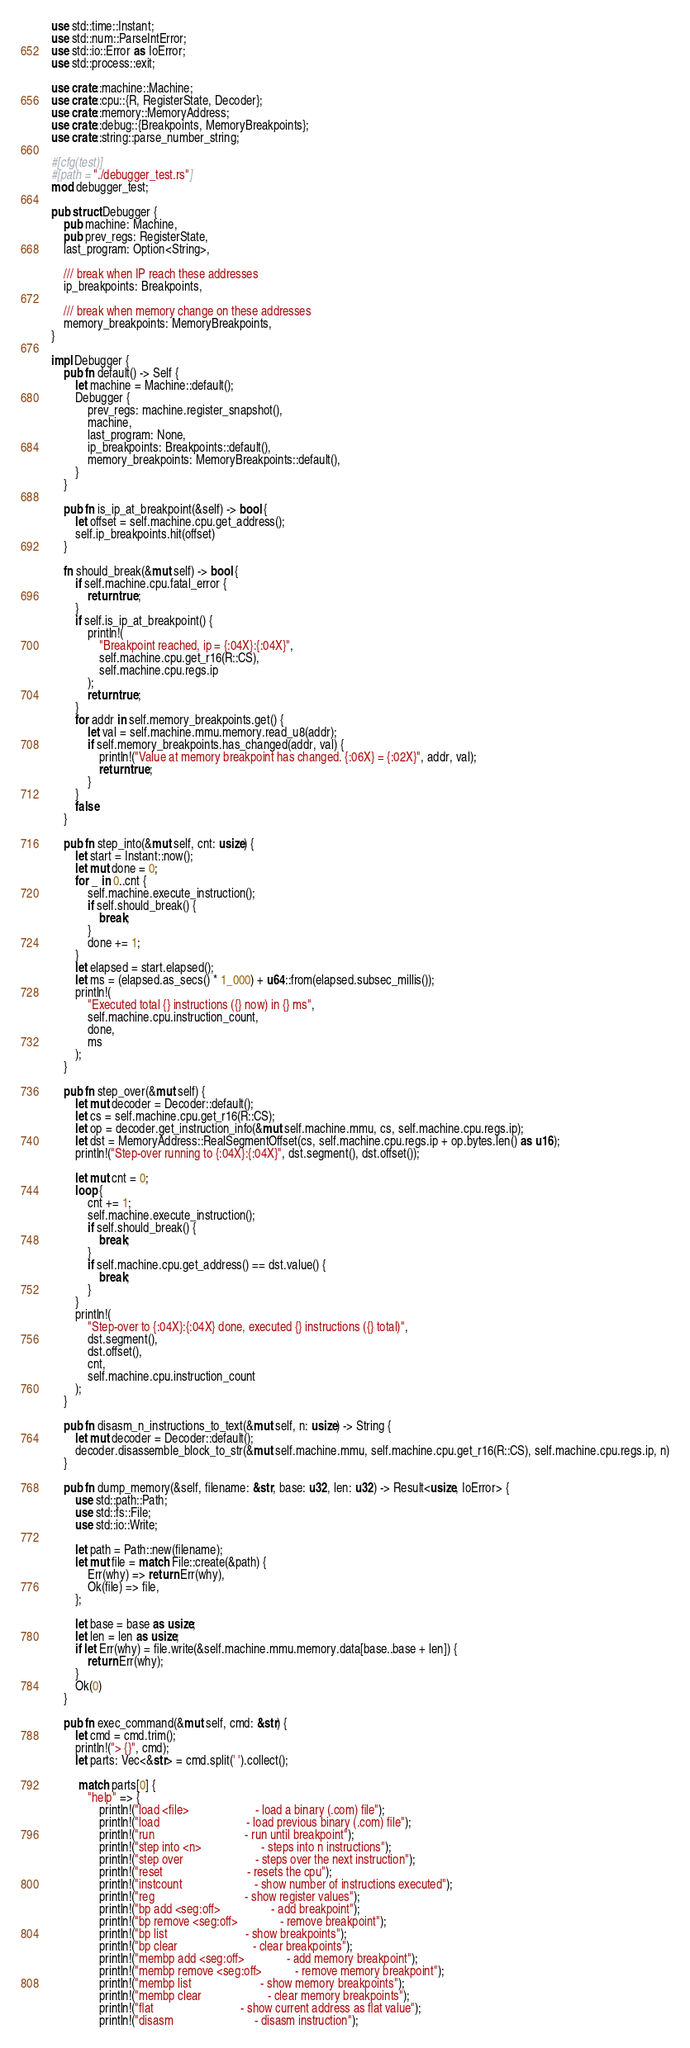Convert code to text. <code><loc_0><loc_0><loc_500><loc_500><_Rust_>use std::time::Instant;
use std::num::ParseIntError;
use std::io::Error as IoError;
use std::process::exit;

use crate::machine::Machine;
use crate::cpu::{R, RegisterState, Decoder};
use crate::memory::MemoryAddress;
use crate::debug::{Breakpoints, MemoryBreakpoints};
use crate::string::parse_number_string;

#[cfg(test)]
#[path = "./debugger_test.rs"]
mod debugger_test;

pub struct Debugger {
    pub machine: Machine,
    pub prev_regs: RegisterState,
    last_program: Option<String>,

    /// break when IP reach these addresses
    ip_breakpoints: Breakpoints,

    /// break when memory change on these addresses
    memory_breakpoints: MemoryBreakpoints,
}

impl Debugger {
    pub fn default() -> Self {
        let machine = Machine::default();
        Debugger {
            prev_regs: machine.register_snapshot(),
            machine,
            last_program: None,
            ip_breakpoints: Breakpoints::default(),
            memory_breakpoints: MemoryBreakpoints::default(),
        }
    }

    pub fn is_ip_at_breakpoint(&self) -> bool {
        let offset = self.machine.cpu.get_address();
        self.ip_breakpoints.hit(offset)
    }

    fn should_break(&mut self) -> bool {
        if self.machine.cpu.fatal_error {
            return true;
        }
        if self.is_ip_at_breakpoint() {
            println!(
                "Breakpoint reached, ip = {:04X}:{:04X}",
                self.machine.cpu.get_r16(R::CS),
                self.machine.cpu.regs.ip
            );
            return true;
        }
        for addr in self.memory_breakpoints.get() {
            let val = self.machine.mmu.memory.read_u8(addr);
            if self.memory_breakpoints.has_changed(addr, val) {
                println!("Value at memory breakpoint has changed. {:06X} = {:02X}", addr, val);
                return true;
            }
        }
        false
    }

    pub fn step_into(&mut self, cnt: usize) {
        let start = Instant::now();
        let mut done = 0;
        for _ in 0..cnt {
            self.machine.execute_instruction();
            if self.should_break() {
                break;
            }
            done += 1;
        }
        let elapsed = start.elapsed();
        let ms = (elapsed.as_secs() * 1_000) + u64::from(elapsed.subsec_millis());
        println!(
            "Executed total {} instructions ({} now) in {} ms",
            self.machine.cpu.instruction_count,
            done,
            ms
        );
    }

    pub fn step_over(&mut self) {
        let mut decoder = Decoder::default();
        let cs = self.machine.cpu.get_r16(R::CS);
        let op = decoder.get_instruction_info(&mut self.machine.mmu, cs, self.machine.cpu.regs.ip);
        let dst = MemoryAddress::RealSegmentOffset(cs, self.machine.cpu.regs.ip + op.bytes.len() as u16);
        println!("Step-over running to {:04X}:{:04X}", dst.segment(), dst.offset());

        let mut cnt = 0;
        loop {
            cnt += 1;
            self.machine.execute_instruction();
            if self.should_break() {
                break;
            }
            if self.machine.cpu.get_address() == dst.value() {
                break;
            }
        }
        println!(
            "Step-over to {:04X}:{:04X} done, executed {} instructions ({} total)",
            dst.segment(),
            dst.offset(),
            cnt,
            self.machine.cpu.instruction_count
        );
    }

    pub fn disasm_n_instructions_to_text(&mut self, n: usize) -> String {
        let mut decoder = Decoder::default();
        decoder.disassemble_block_to_str(&mut self.machine.mmu, self.machine.cpu.get_r16(R::CS), self.machine.cpu.regs.ip, n)
    }

    pub fn dump_memory(&self, filename: &str, base: u32, len: u32) -> Result<usize, IoError> {
        use std::path::Path;
        use std::fs::File;
        use std::io::Write;

        let path = Path::new(filename);
        let mut file = match File::create(&path) {
            Err(why) => return Err(why),
            Ok(file) => file,
        };

        let base = base as usize;
        let len = len as usize;
        if let Err(why) = file.write(&self.machine.mmu.memory.data[base..base + len]) {
            return Err(why);
        }
        Ok(0)
    }

    pub fn exec_command(&mut self, cmd: &str) {
        let cmd = cmd.trim();
        println!("> {}", cmd);
        let parts: Vec<&str> = cmd.split(' ').collect();

         match parts[0] {
            "help" => {
                println!("load <file>                      - load a binary (.com) file");
                println!("load                             - load previous binary (.com) file");
                println!("run                              - run until breakpoint");
                println!("step into <n>                    - steps into n instructions");
                println!("step over                        - steps over the next instruction");
                println!("reset                            - resets the cpu");
                println!("instcount                        - show number of instructions executed");
                println!("reg                              - show register values");
                println!("bp add <seg:off>                 - add breakpoint");
                println!("bp remove <seg:off>              - remove breakpoint");
                println!("bp list                          - show breakpoints");
                println!("bp clear                         - clear breakpoints");
                println!("membp add <seg:off>              - add memory breakpoint");
                println!("membp remove <seg:off>           - remove memory breakpoint");
                println!("membp list                       - show memory breakpoints");
                println!("membp clear                      - clear memory breakpoints");
                println!("flat                             - show current address as flat value");
                println!("disasm                           - disasm instruction");</code> 